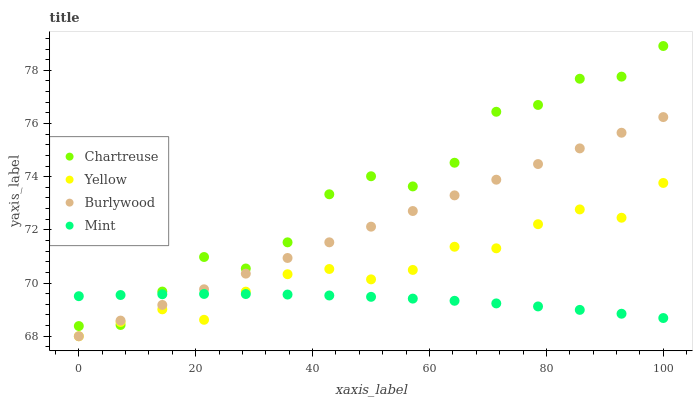Does Mint have the minimum area under the curve?
Answer yes or no. Yes. Does Chartreuse have the maximum area under the curve?
Answer yes or no. Yes. Does Chartreuse have the minimum area under the curve?
Answer yes or no. No. Does Mint have the maximum area under the curve?
Answer yes or no. No. Is Burlywood the smoothest?
Answer yes or no. Yes. Is Chartreuse the roughest?
Answer yes or no. Yes. Is Mint the smoothest?
Answer yes or no. No. Is Mint the roughest?
Answer yes or no. No. Does Burlywood have the lowest value?
Answer yes or no. Yes. Does Chartreuse have the lowest value?
Answer yes or no. No. Does Chartreuse have the highest value?
Answer yes or no. Yes. Does Mint have the highest value?
Answer yes or no. No. Does Burlywood intersect Yellow?
Answer yes or no. Yes. Is Burlywood less than Yellow?
Answer yes or no. No. Is Burlywood greater than Yellow?
Answer yes or no. No. 